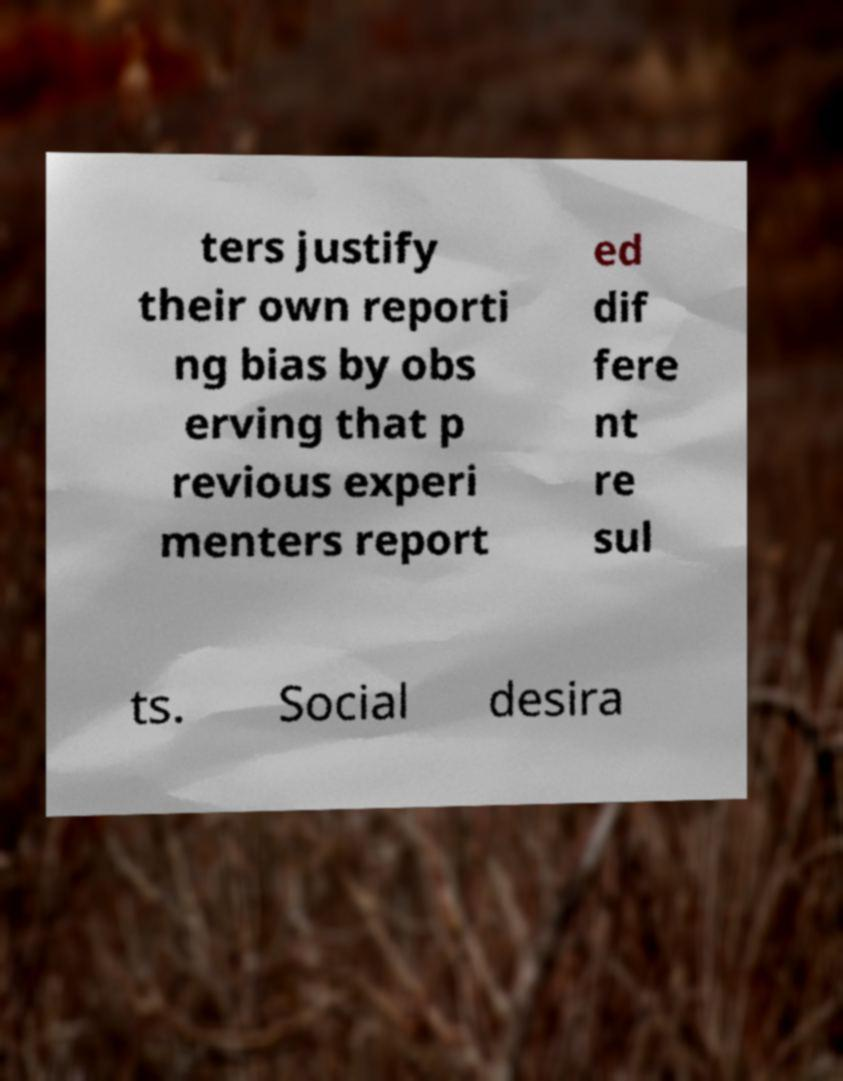What messages or text are displayed in this image? I need them in a readable, typed format. ters justify their own reporti ng bias by obs erving that p revious experi menters report ed dif fere nt re sul ts. Social desira 